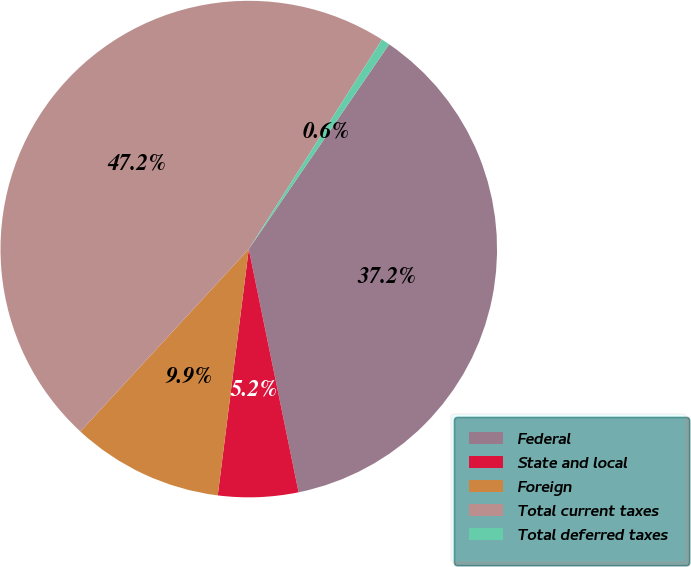Convert chart. <chart><loc_0><loc_0><loc_500><loc_500><pie_chart><fcel>Federal<fcel>State and local<fcel>Foreign<fcel>Total current taxes<fcel>Total deferred taxes<nl><fcel>37.22%<fcel>5.21%<fcel>9.87%<fcel>47.15%<fcel>0.55%<nl></chart> 